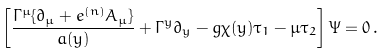<formula> <loc_0><loc_0><loc_500><loc_500>\left [ \frac { \Gamma ^ { \mu } \{ \partial _ { \mu } + e ^ { ( n ) } A _ { \mu } \} } { a ( y ) } + \Gamma ^ { y } \partial _ { y } - g \chi ( y ) \tau _ { 1 } - \mu \tau _ { 2 } \right ] \Psi = 0 \, .</formula> 